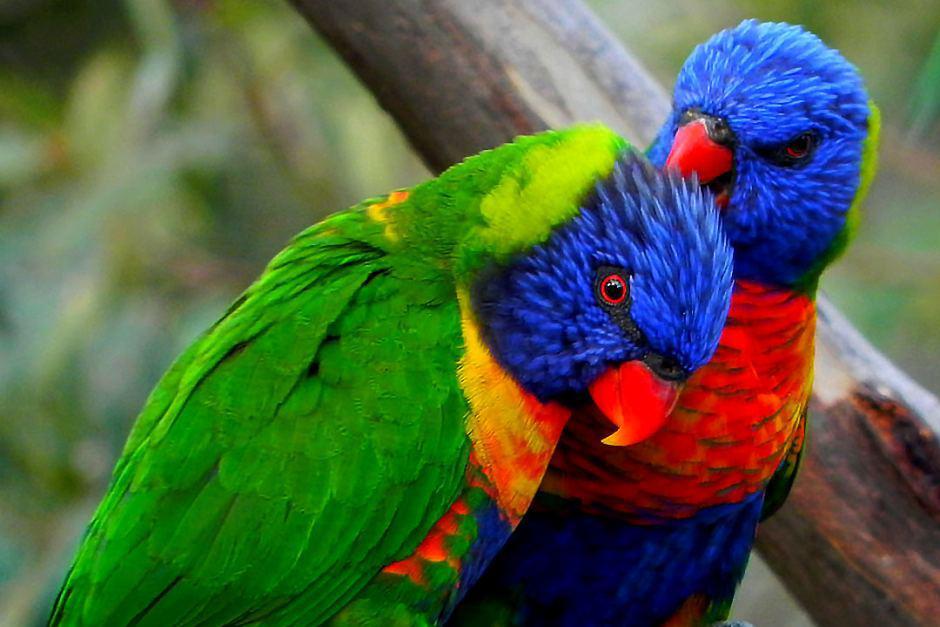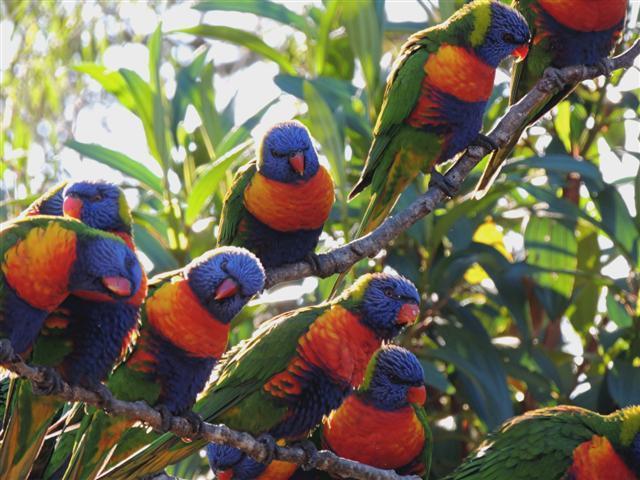The first image is the image on the left, the second image is the image on the right. For the images shown, is this caption "There are two birds" true? Answer yes or no. No. 